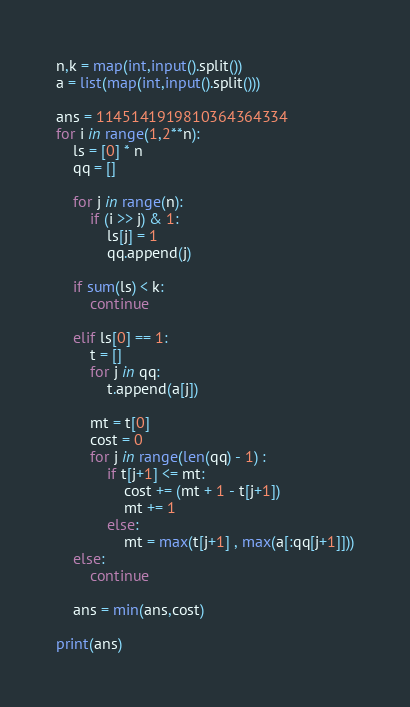Convert code to text. <code><loc_0><loc_0><loc_500><loc_500><_Python_>n,k = map(int,input().split())
a = list(map(int,input().split()))

ans = 1145141919810364364334
for i in range(1,2**n):
    ls = [0] * n
    qq = []
    
    for j in range(n):
        if (i >> j) & 1:
            ls[j] = 1
            qq.append(j)
            
    if sum(ls) < k:
        continue
        
    elif ls[0] == 1:
        t = []
        for j in qq:
            t.append(a[j])
        
        mt = t[0]
        cost = 0
        for j in range(len(qq) - 1) :
            if t[j+1] <= mt:
                cost += (mt + 1 - t[j+1])
                mt += 1
            else:
                mt = max(t[j+1] , max(a[:qq[j+1]]))
    else:
        continue
                
    ans = min(ans,cost)
    
print(ans)</code> 